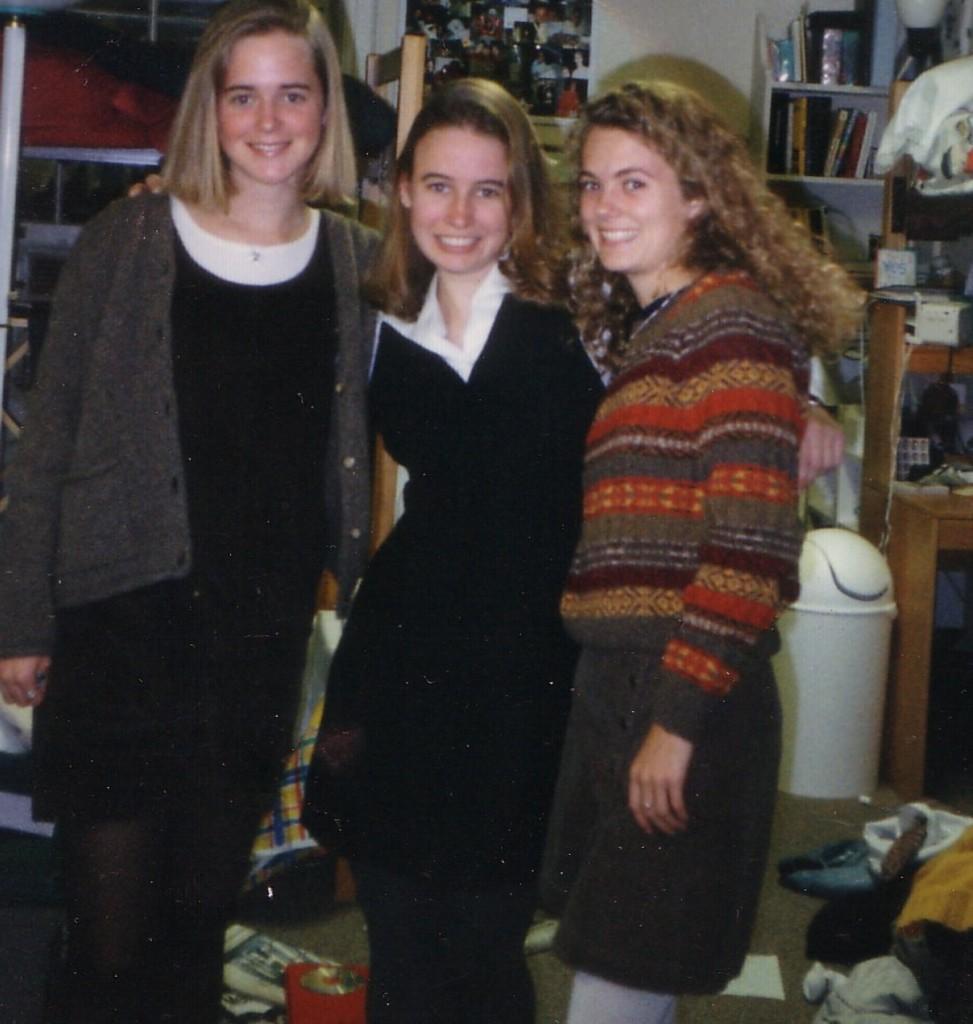Describe this image in one or two sentences. There are three ladies standing and holding each other and there are few other objects behind them. 